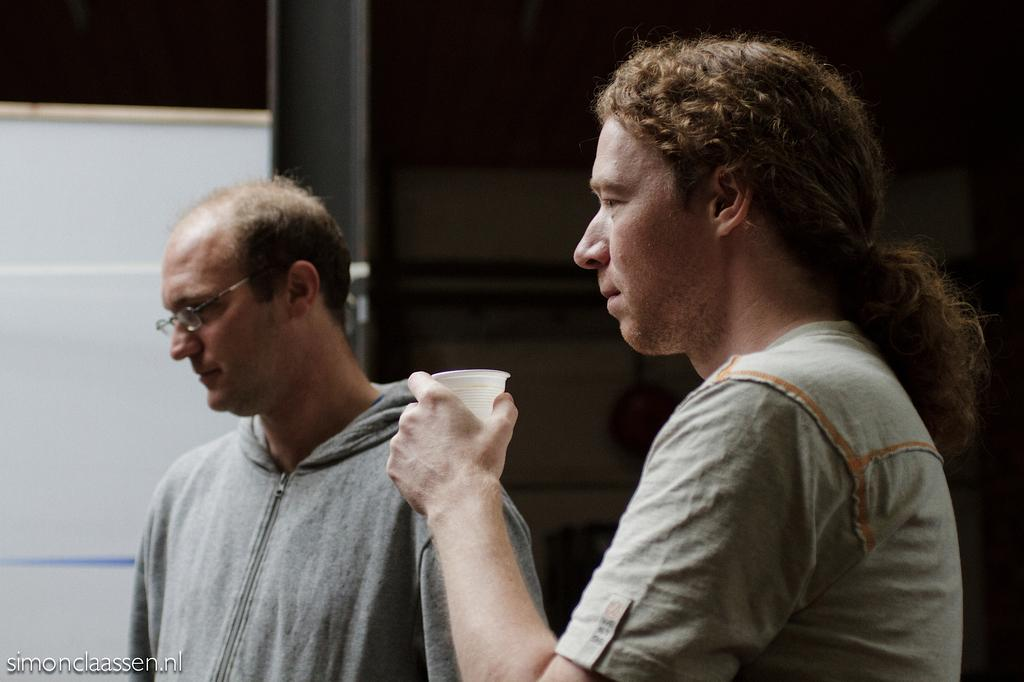How many people are in the image? There are two men in the image. What is one of the men holding in his hand? One of the men is holding a glass in his hand. On which side of the image is the man holding the glass? The man holding the glass is on the right side of the image. Can you describe any additional features of the image? There is a watermark on the bottom left side of the image. What is the cent of respect and desire in the image? There is no mention of a cent, respect, or desire in the image; it only features two men, one of whom is holding a glass. 